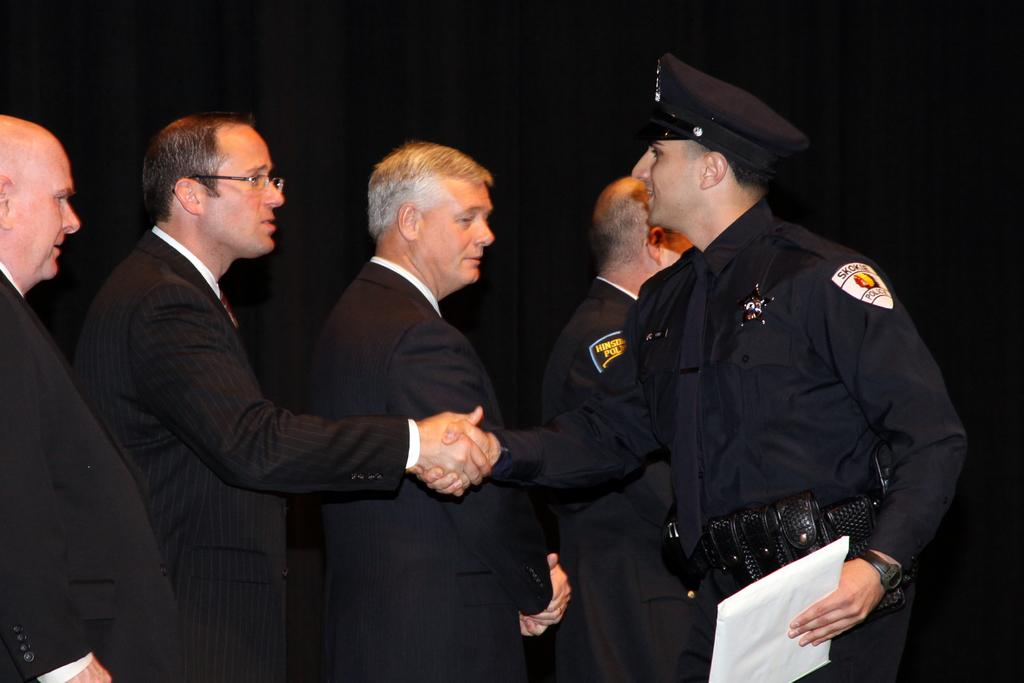How many people are standing in a line in the image? There are four people standing in a line in the image. What is the man in front of the line wearing? The man in front of the line is wearing a uniform. What is the man in the uniform holding? The man in the uniform is holding a paper. What action is the man in the uniform performing with one of the people in the line? The man in the uniform is shaking hands with one of the people in the line. What type of comb is the man in the uniform using to sense the people's minds in the image? There is no comb or mind-reading depicted in the image; the man in the uniform is simply shaking hands with one of the people in the line. 